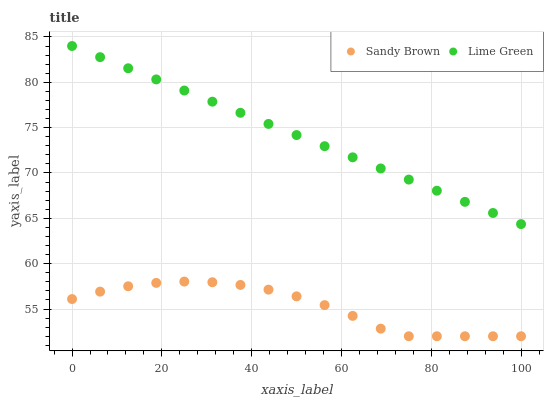Does Sandy Brown have the minimum area under the curve?
Answer yes or no. Yes. Does Lime Green have the maximum area under the curve?
Answer yes or no. Yes. Does Sandy Brown have the maximum area under the curve?
Answer yes or no. No. Is Lime Green the smoothest?
Answer yes or no. Yes. Is Sandy Brown the roughest?
Answer yes or no. Yes. Is Sandy Brown the smoothest?
Answer yes or no. No. Does Sandy Brown have the lowest value?
Answer yes or no. Yes. Does Lime Green have the highest value?
Answer yes or no. Yes. Does Sandy Brown have the highest value?
Answer yes or no. No. Is Sandy Brown less than Lime Green?
Answer yes or no. Yes. Is Lime Green greater than Sandy Brown?
Answer yes or no. Yes. Does Sandy Brown intersect Lime Green?
Answer yes or no. No. 